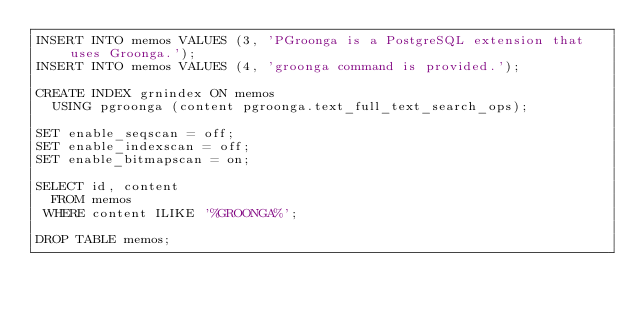Convert code to text. <code><loc_0><loc_0><loc_500><loc_500><_SQL_>INSERT INTO memos VALUES (3, 'PGroonga is a PostgreSQL extension that uses Groonga.');
INSERT INTO memos VALUES (4, 'groonga command is provided.');

CREATE INDEX grnindex ON memos
  USING pgroonga (content pgroonga.text_full_text_search_ops);

SET enable_seqscan = off;
SET enable_indexscan = off;
SET enable_bitmapscan = on;

SELECT id, content
  FROM memos
 WHERE content ILIKE '%GROONGA%';

DROP TABLE memos;
</code> 